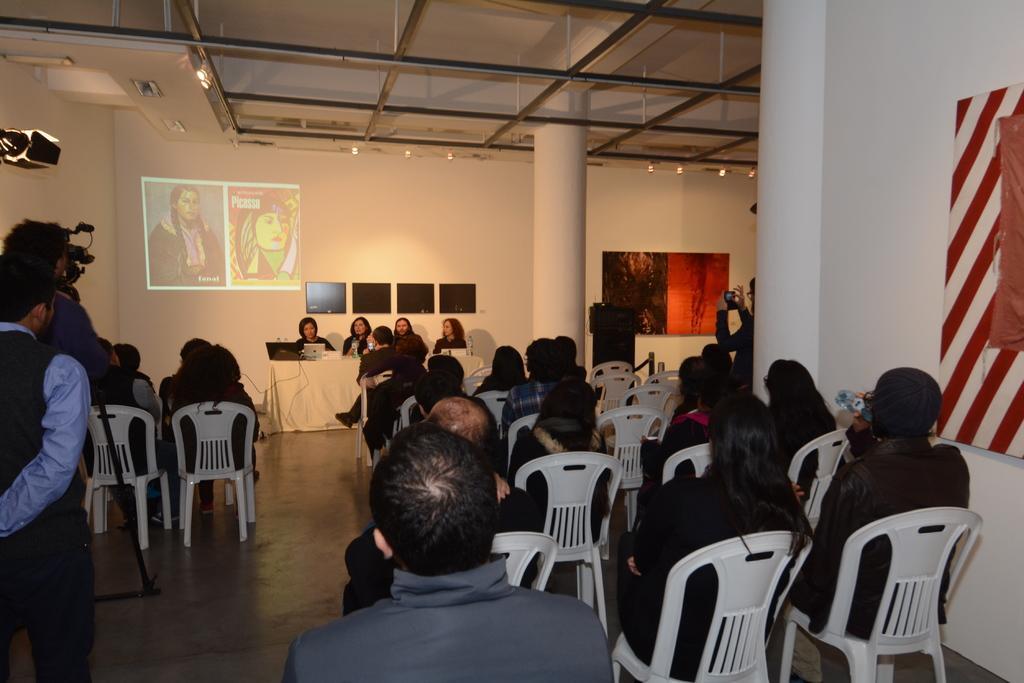Please provide a concise description of this image. There are group of people sitting on the chairs. This is a table covered with white cloth. There is a laptop and few other things placed on the table. This is a pillar which is white in color. I think these are the screens attached to the wall. There are two people standing and one person is recording video. This looks like a display on the wall. These are the posters attached on the wall. This is the rooftop. I can see few empty chairs. 